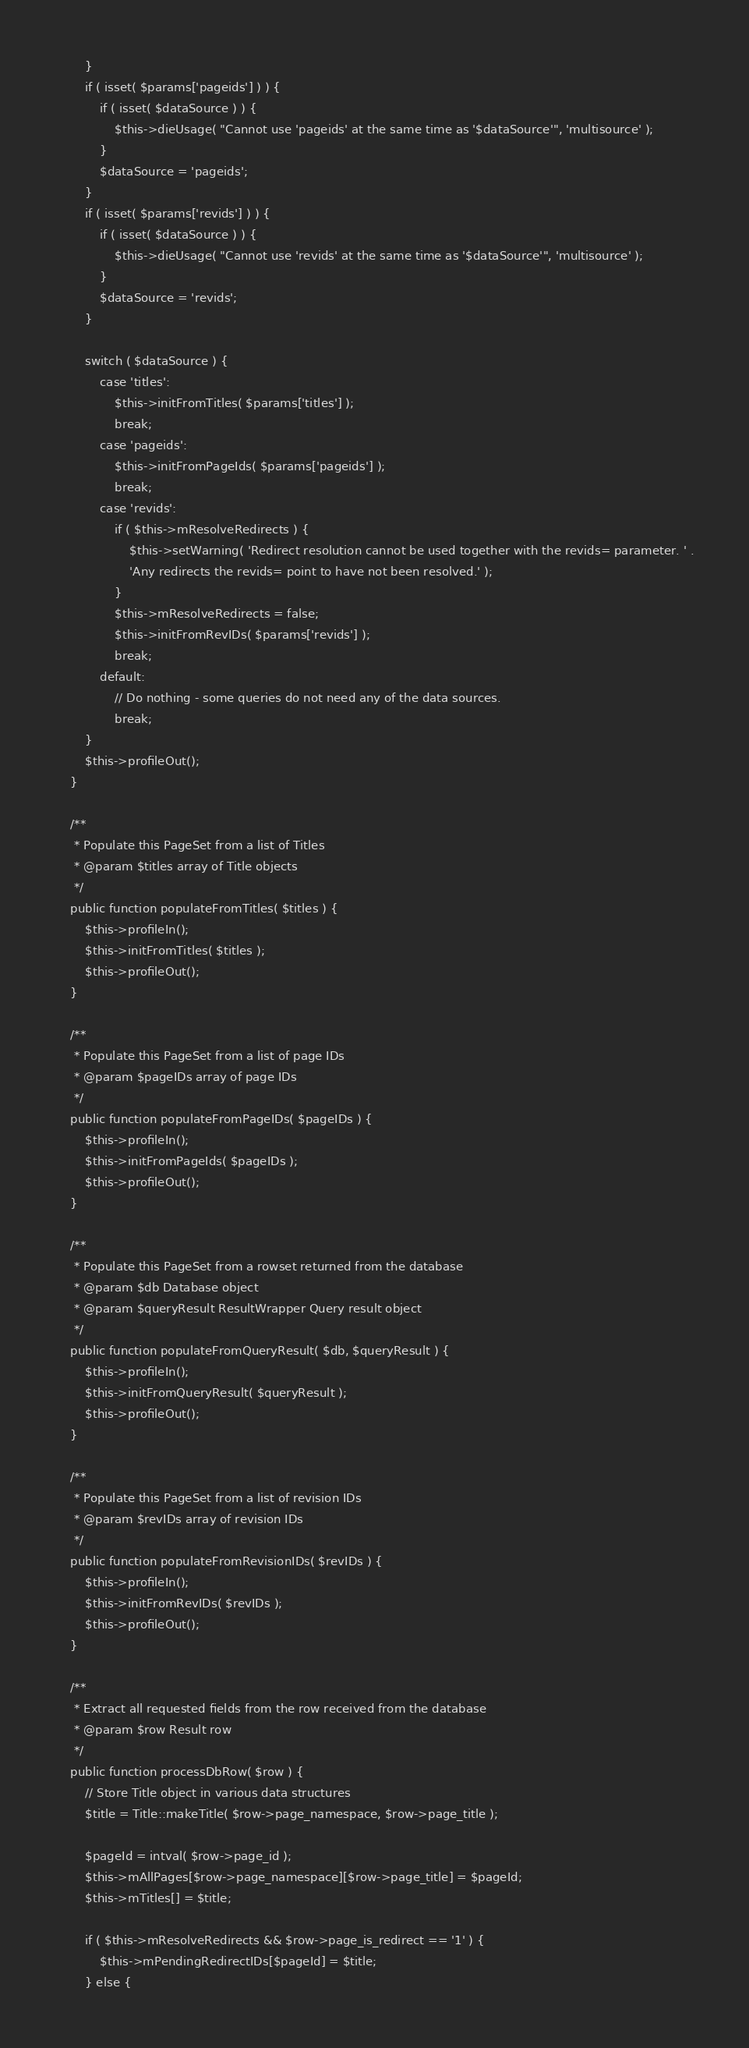Convert code to text. <code><loc_0><loc_0><loc_500><loc_500><_PHP_>		}
		if ( isset( $params['pageids'] ) ) {
			if ( isset( $dataSource ) ) {
				$this->dieUsage( "Cannot use 'pageids' at the same time as '$dataSource'", 'multisource' );
			}
			$dataSource = 'pageids';
		}
		if ( isset( $params['revids'] ) ) {
			if ( isset( $dataSource ) ) {
				$this->dieUsage( "Cannot use 'revids' at the same time as '$dataSource'", 'multisource' );
			}
			$dataSource = 'revids';
		}

		switch ( $dataSource ) {
			case 'titles':
				$this->initFromTitles( $params['titles'] );
				break;
			case 'pageids':
				$this->initFromPageIds( $params['pageids'] );
				break;
			case 'revids':
				if ( $this->mResolveRedirects ) {
					$this->setWarning( 'Redirect resolution cannot be used together with the revids= parameter. ' .
					'Any redirects the revids= point to have not been resolved.' );
				}
				$this->mResolveRedirects = false;
				$this->initFromRevIDs( $params['revids'] );
				break;
			default:
				// Do nothing - some queries do not need any of the data sources.
				break;
		}
		$this->profileOut();
	}

	/**
	 * Populate this PageSet from a list of Titles
	 * @param $titles array of Title objects
	 */
	public function populateFromTitles( $titles ) {
		$this->profileIn();
		$this->initFromTitles( $titles );
		$this->profileOut();
	}

	/**
	 * Populate this PageSet from a list of page IDs
	 * @param $pageIDs array of page IDs
	 */
	public function populateFromPageIDs( $pageIDs ) {
		$this->profileIn();
		$this->initFromPageIds( $pageIDs );
		$this->profileOut();
	}

	/**
	 * Populate this PageSet from a rowset returned from the database
	 * @param $db Database object
	 * @param $queryResult ResultWrapper Query result object
	 */
	public function populateFromQueryResult( $db, $queryResult ) {
		$this->profileIn();
		$this->initFromQueryResult( $queryResult );
		$this->profileOut();
	}

	/**
	 * Populate this PageSet from a list of revision IDs
	 * @param $revIDs array of revision IDs
	 */
	public function populateFromRevisionIDs( $revIDs ) {
		$this->profileIn();
		$this->initFromRevIDs( $revIDs );
		$this->profileOut();
	}

	/**
	 * Extract all requested fields from the row received from the database
	 * @param $row Result row
	 */
	public function processDbRow( $row ) {
		// Store Title object in various data structures
		$title = Title::makeTitle( $row->page_namespace, $row->page_title );

		$pageId = intval( $row->page_id );
		$this->mAllPages[$row->page_namespace][$row->page_title] = $pageId;
		$this->mTitles[] = $title;

		if ( $this->mResolveRedirects && $row->page_is_redirect == '1' ) {
			$this->mPendingRedirectIDs[$pageId] = $title;
		} else {</code> 